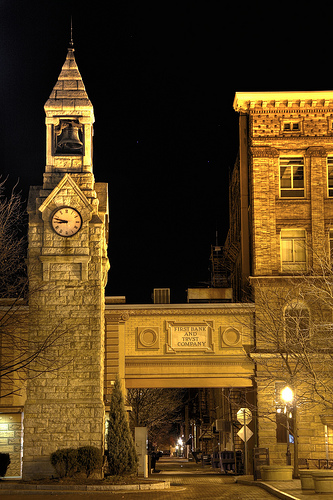<image>
Is the clock under the bell? Yes. The clock is positioned underneath the bell, with the bell above it in the vertical space. Is the lightpost behind the tree? No. The lightpost is not behind the tree. From this viewpoint, the lightpost appears to be positioned elsewhere in the scene. 